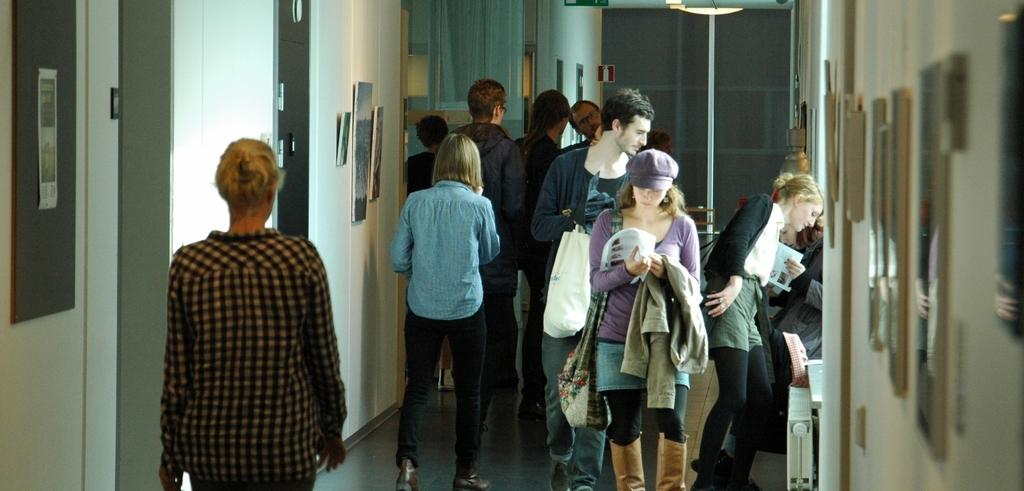How many people are in the image? There is a group of people standing in the image. What can be seen on the wall in the image? There are frames attached to the wall in the image. Can you describe the light source in the image? There is a light source in the image, but its specific details are not mentioned. How much money is being exchanged between the people in the image? There is no mention of money or any exchange of money in the image. Can you see a rat in the image? There is no rat present in the image. 